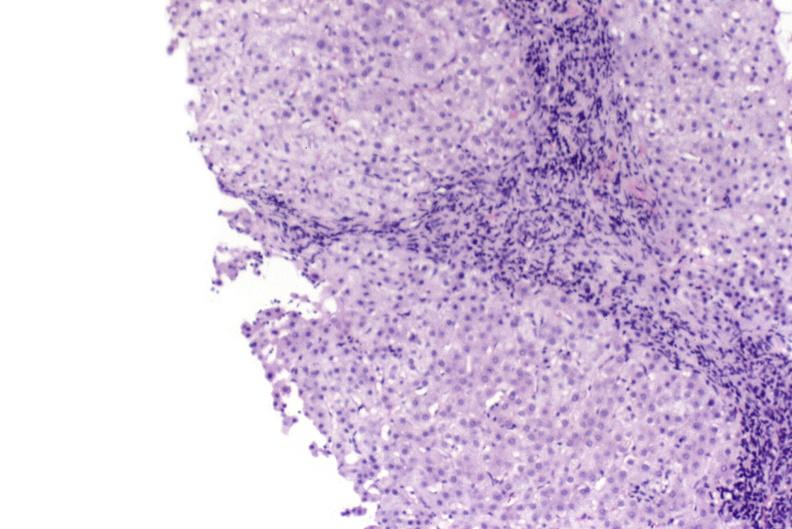does this image show primary biliary cirrhosis?
Answer the question using a single word or phrase. Yes 